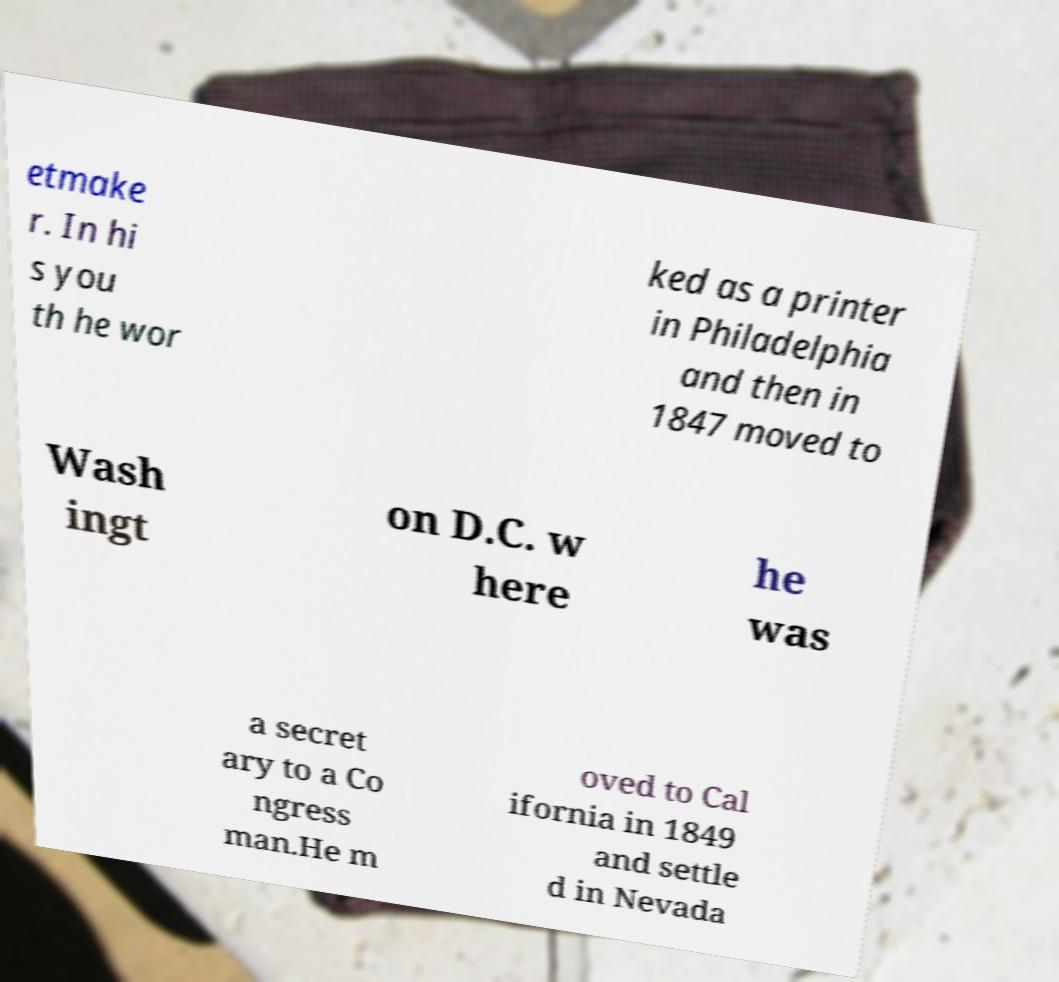Can you read and provide the text displayed in the image?This photo seems to have some interesting text. Can you extract and type it out for me? etmake r. In hi s you th he wor ked as a printer in Philadelphia and then in 1847 moved to Wash ingt on D.C. w here he was a secret ary to a Co ngress man.He m oved to Cal ifornia in 1849 and settle d in Nevada 